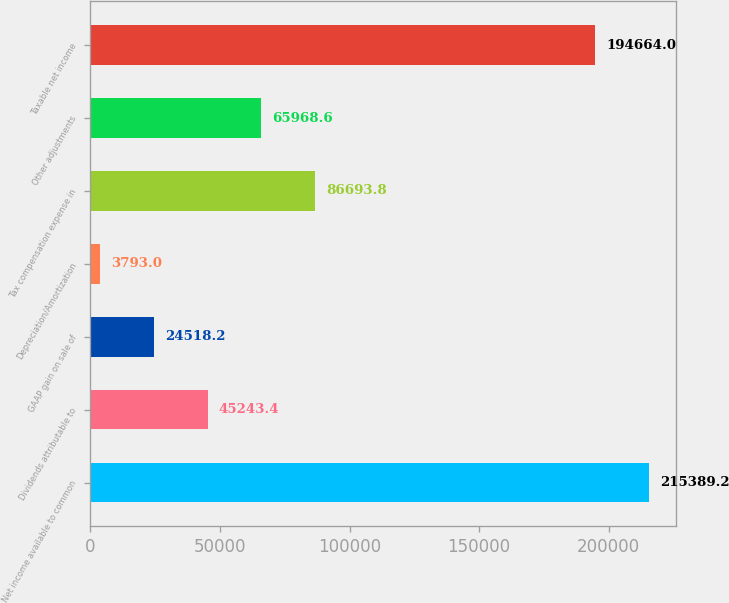Convert chart to OTSL. <chart><loc_0><loc_0><loc_500><loc_500><bar_chart><fcel>Net income available to common<fcel>Dividends attributable to<fcel>GAAP gain on sale of<fcel>Depreciation/Amortization<fcel>Tax compensation expense in<fcel>Other adjustments<fcel>Taxable net income<nl><fcel>215389<fcel>45243.4<fcel>24518.2<fcel>3793<fcel>86693.8<fcel>65968.6<fcel>194664<nl></chart> 